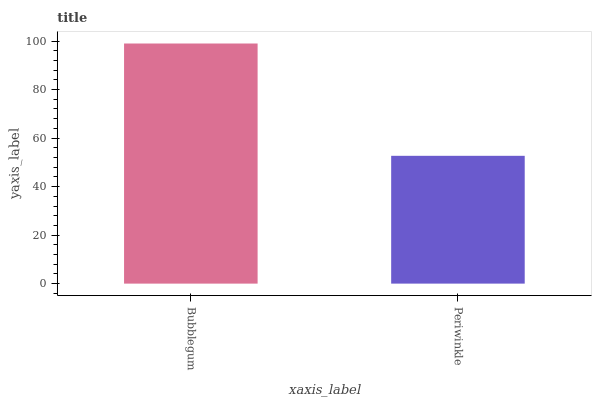Is Periwinkle the maximum?
Answer yes or no. No. Is Bubblegum greater than Periwinkle?
Answer yes or no. Yes. Is Periwinkle less than Bubblegum?
Answer yes or no. Yes. Is Periwinkle greater than Bubblegum?
Answer yes or no. No. Is Bubblegum less than Periwinkle?
Answer yes or no. No. Is Bubblegum the high median?
Answer yes or no. Yes. Is Periwinkle the low median?
Answer yes or no. Yes. Is Periwinkle the high median?
Answer yes or no. No. Is Bubblegum the low median?
Answer yes or no. No. 